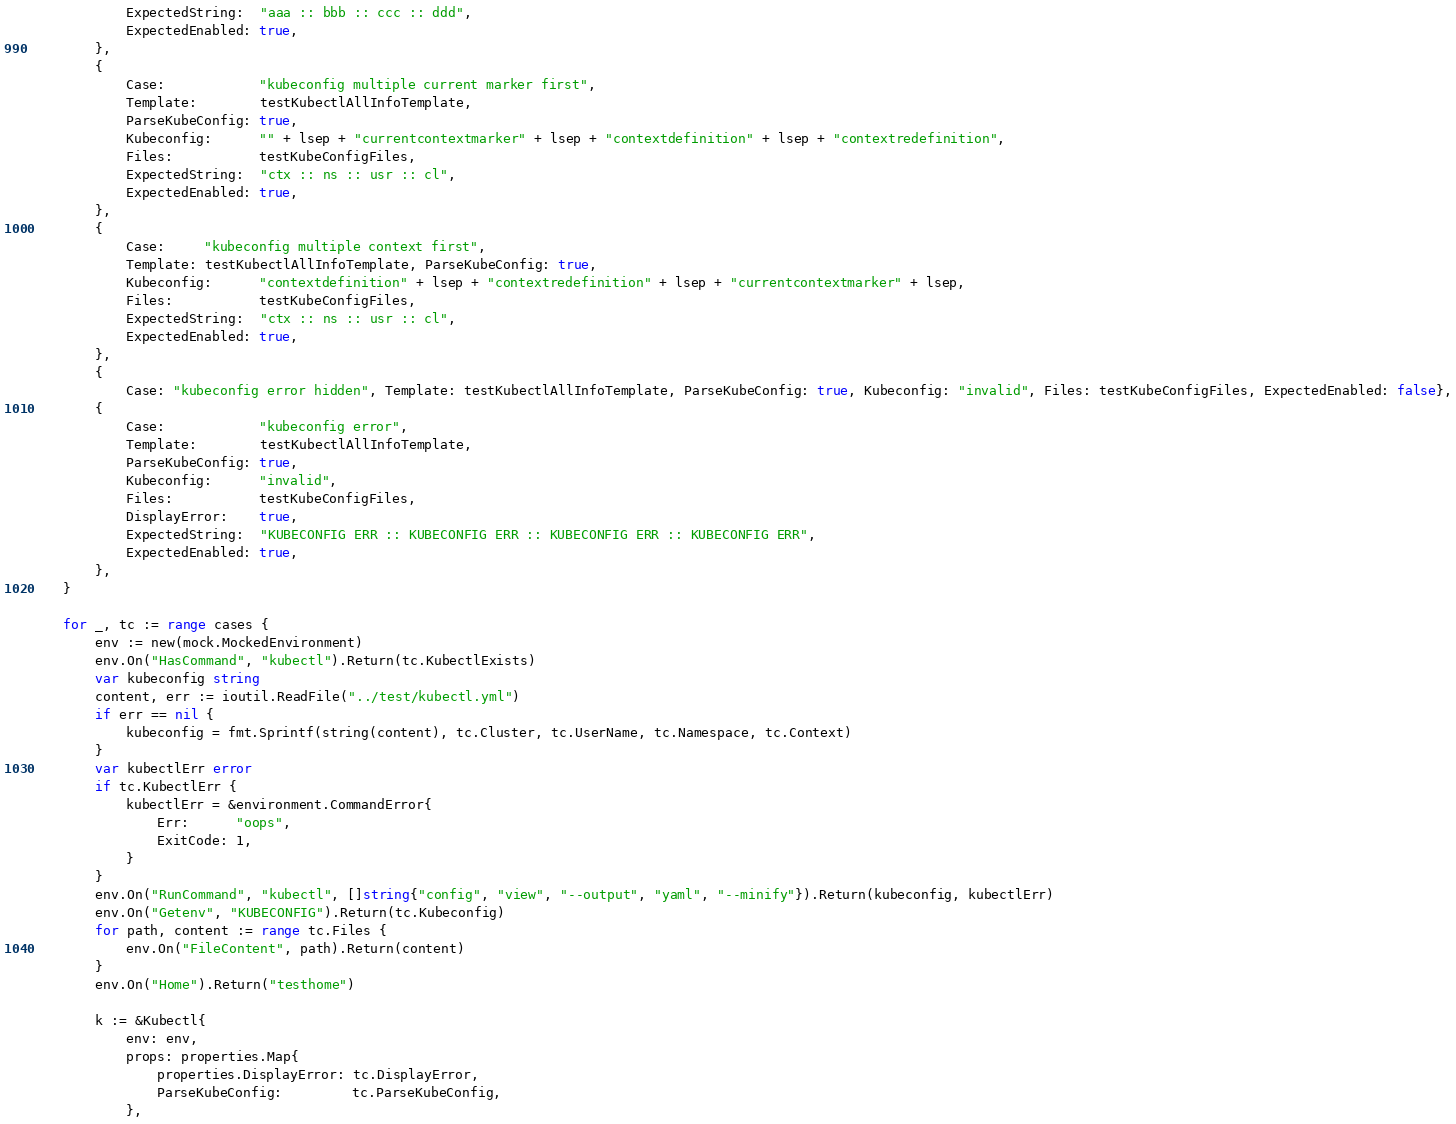<code> <loc_0><loc_0><loc_500><loc_500><_Go_>			ExpectedString:  "aaa :: bbb :: ccc :: ddd",
			ExpectedEnabled: true,
		},
		{
			Case:            "kubeconfig multiple current marker first",
			Template:        testKubectlAllInfoTemplate,
			ParseKubeConfig: true,
			Kubeconfig:      "" + lsep + "currentcontextmarker" + lsep + "contextdefinition" + lsep + "contextredefinition",
			Files:           testKubeConfigFiles,
			ExpectedString:  "ctx :: ns :: usr :: cl",
			ExpectedEnabled: true,
		},
		{
			Case:     "kubeconfig multiple context first",
			Template: testKubectlAllInfoTemplate, ParseKubeConfig: true,
			Kubeconfig:      "contextdefinition" + lsep + "contextredefinition" + lsep + "currentcontextmarker" + lsep,
			Files:           testKubeConfigFiles,
			ExpectedString:  "ctx :: ns :: usr :: cl",
			ExpectedEnabled: true,
		},
		{
			Case: "kubeconfig error hidden", Template: testKubectlAllInfoTemplate, ParseKubeConfig: true, Kubeconfig: "invalid", Files: testKubeConfigFiles, ExpectedEnabled: false},
		{
			Case:            "kubeconfig error",
			Template:        testKubectlAllInfoTemplate,
			ParseKubeConfig: true,
			Kubeconfig:      "invalid",
			Files:           testKubeConfigFiles,
			DisplayError:    true,
			ExpectedString:  "KUBECONFIG ERR :: KUBECONFIG ERR :: KUBECONFIG ERR :: KUBECONFIG ERR",
			ExpectedEnabled: true,
		},
	}

	for _, tc := range cases {
		env := new(mock.MockedEnvironment)
		env.On("HasCommand", "kubectl").Return(tc.KubectlExists)
		var kubeconfig string
		content, err := ioutil.ReadFile("../test/kubectl.yml")
		if err == nil {
			kubeconfig = fmt.Sprintf(string(content), tc.Cluster, tc.UserName, tc.Namespace, tc.Context)
		}
		var kubectlErr error
		if tc.KubectlErr {
			kubectlErr = &environment.CommandError{
				Err:      "oops",
				ExitCode: 1,
			}
		}
		env.On("RunCommand", "kubectl", []string{"config", "view", "--output", "yaml", "--minify"}).Return(kubeconfig, kubectlErr)
		env.On("Getenv", "KUBECONFIG").Return(tc.Kubeconfig)
		for path, content := range tc.Files {
			env.On("FileContent", path).Return(content)
		}
		env.On("Home").Return("testhome")

		k := &Kubectl{
			env: env,
			props: properties.Map{
				properties.DisplayError: tc.DisplayError,
				ParseKubeConfig:         tc.ParseKubeConfig,
			},</code> 